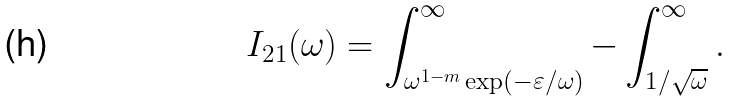Convert formula to latex. <formula><loc_0><loc_0><loc_500><loc_500>I _ { 2 1 } ( \omega ) = \int _ { \omega ^ { 1 - m } \exp \left ( - \varepsilon / \omega \right ) } ^ { \infty } - \int _ { 1 / \sqrt { \omega } } ^ { \infty } .</formula> 